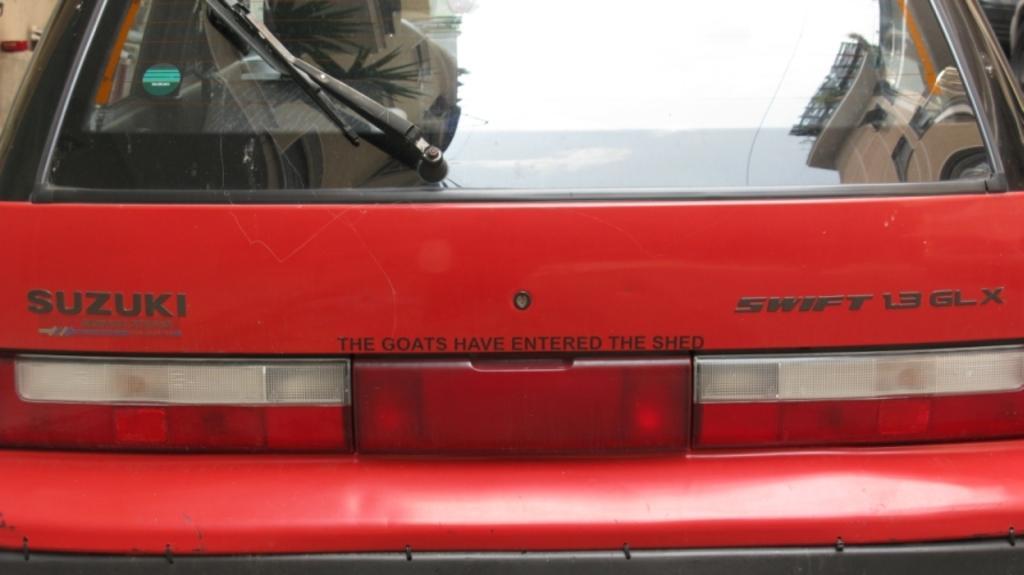Can you describe this image briefly? In this image I can see the car which is in red color. I can see the name Suzuki is written on it. 